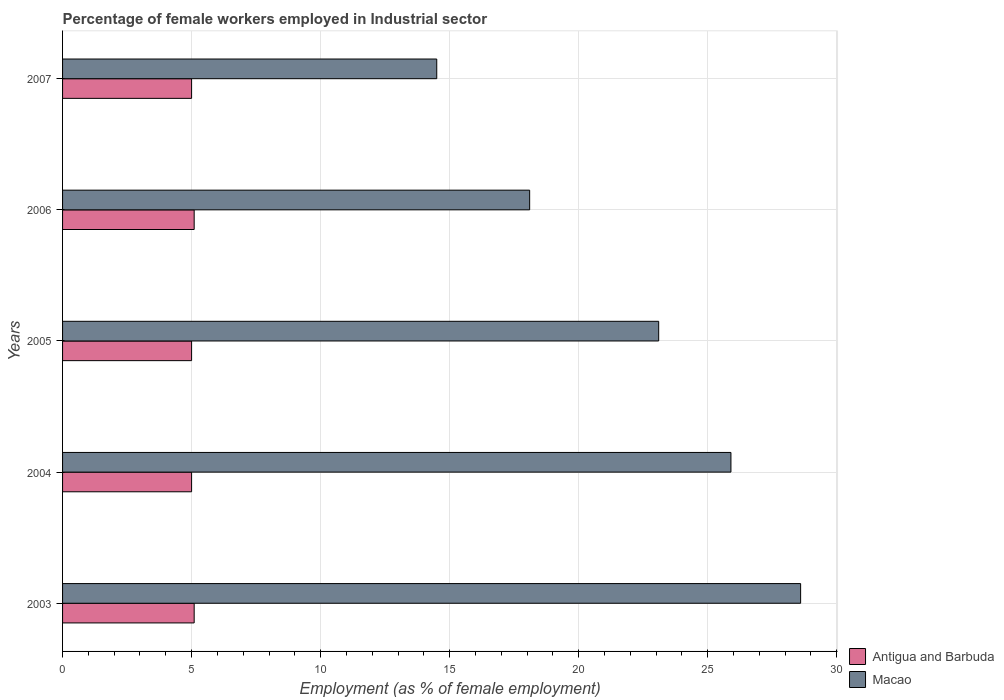Are the number of bars per tick equal to the number of legend labels?
Offer a terse response. Yes. Are the number of bars on each tick of the Y-axis equal?
Provide a short and direct response. Yes. In how many cases, is the number of bars for a given year not equal to the number of legend labels?
Your answer should be compact. 0. Across all years, what is the maximum percentage of females employed in Industrial sector in Macao?
Offer a terse response. 28.6. Across all years, what is the minimum percentage of females employed in Industrial sector in Macao?
Keep it short and to the point. 14.5. In which year was the percentage of females employed in Industrial sector in Antigua and Barbuda maximum?
Give a very brief answer. 2003. What is the total percentage of females employed in Industrial sector in Antigua and Barbuda in the graph?
Keep it short and to the point. 25.2. What is the difference between the percentage of females employed in Industrial sector in Antigua and Barbuda in 2004 and that in 2007?
Offer a terse response. 0. What is the difference between the percentage of females employed in Industrial sector in Macao in 2004 and the percentage of females employed in Industrial sector in Antigua and Barbuda in 2003?
Provide a succinct answer. 20.8. What is the average percentage of females employed in Industrial sector in Macao per year?
Offer a very short reply. 22.04. In how many years, is the percentage of females employed in Industrial sector in Antigua and Barbuda greater than 11 %?
Make the answer very short. 0. What is the ratio of the percentage of females employed in Industrial sector in Antigua and Barbuda in 2003 to that in 2007?
Provide a short and direct response. 1.02. Is the percentage of females employed in Industrial sector in Macao in 2003 less than that in 2006?
Make the answer very short. No. Is the difference between the percentage of females employed in Industrial sector in Macao in 2003 and 2006 greater than the difference between the percentage of females employed in Industrial sector in Antigua and Barbuda in 2003 and 2006?
Ensure brevity in your answer.  Yes. What is the difference between the highest and the second highest percentage of females employed in Industrial sector in Macao?
Give a very brief answer. 2.7. What is the difference between the highest and the lowest percentage of females employed in Industrial sector in Antigua and Barbuda?
Your answer should be very brief. 0.1. Is the sum of the percentage of females employed in Industrial sector in Antigua and Barbuda in 2003 and 2006 greater than the maximum percentage of females employed in Industrial sector in Macao across all years?
Provide a short and direct response. No. What does the 1st bar from the top in 2005 represents?
Offer a very short reply. Macao. What does the 1st bar from the bottom in 2003 represents?
Provide a short and direct response. Antigua and Barbuda. How many bars are there?
Provide a succinct answer. 10. How many years are there in the graph?
Provide a succinct answer. 5. What is the difference between two consecutive major ticks on the X-axis?
Provide a succinct answer. 5. What is the title of the graph?
Your response must be concise. Percentage of female workers employed in Industrial sector. Does "Costa Rica" appear as one of the legend labels in the graph?
Offer a terse response. No. What is the label or title of the X-axis?
Offer a very short reply. Employment (as % of female employment). What is the Employment (as % of female employment) in Antigua and Barbuda in 2003?
Your answer should be compact. 5.1. What is the Employment (as % of female employment) of Macao in 2003?
Your answer should be compact. 28.6. What is the Employment (as % of female employment) of Macao in 2004?
Your answer should be very brief. 25.9. What is the Employment (as % of female employment) in Macao in 2005?
Make the answer very short. 23.1. What is the Employment (as % of female employment) of Antigua and Barbuda in 2006?
Ensure brevity in your answer.  5.1. What is the Employment (as % of female employment) in Macao in 2006?
Provide a succinct answer. 18.1. What is the Employment (as % of female employment) of Antigua and Barbuda in 2007?
Provide a short and direct response. 5. What is the Employment (as % of female employment) in Macao in 2007?
Ensure brevity in your answer.  14.5. Across all years, what is the maximum Employment (as % of female employment) in Antigua and Barbuda?
Provide a succinct answer. 5.1. Across all years, what is the maximum Employment (as % of female employment) in Macao?
Give a very brief answer. 28.6. Across all years, what is the minimum Employment (as % of female employment) in Macao?
Your answer should be very brief. 14.5. What is the total Employment (as % of female employment) of Antigua and Barbuda in the graph?
Make the answer very short. 25.2. What is the total Employment (as % of female employment) of Macao in the graph?
Your response must be concise. 110.2. What is the difference between the Employment (as % of female employment) in Antigua and Barbuda in 2003 and that in 2004?
Ensure brevity in your answer.  0.1. What is the difference between the Employment (as % of female employment) of Macao in 2004 and that in 2005?
Make the answer very short. 2.8. What is the difference between the Employment (as % of female employment) in Antigua and Barbuda in 2004 and that in 2006?
Ensure brevity in your answer.  -0.1. What is the difference between the Employment (as % of female employment) in Antigua and Barbuda in 2004 and that in 2007?
Your response must be concise. 0. What is the difference between the Employment (as % of female employment) in Macao in 2005 and that in 2007?
Your answer should be very brief. 8.6. What is the difference between the Employment (as % of female employment) of Antigua and Barbuda in 2006 and that in 2007?
Provide a succinct answer. 0.1. What is the difference between the Employment (as % of female employment) of Macao in 2006 and that in 2007?
Offer a very short reply. 3.6. What is the difference between the Employment (as % of female employment) in Antigua and Barbuda in 2003 and the Employment (as % of female employment) in Macao in 2004?
Provide a succinct answer. -20.8. What is the difference between the Employment (as % of female employment) of Antigua and Barbuda in 2003 and the Employment (as % of female employment) of Macao in 2006?
Provide a short and direct response. -13. What is the difference between the Employment (as % of female employment) of Antigua and Barbuda in 2004 and the Employment (as % of female employment) of Macao in 2005?
Your answer should be compact. -18.1. What is the difference between the Employment (as % of female employment) of Antigua and Barbuda in 2006 and the Employment (as % of female employment) of Macao in 2007?
Offer a very short reply. -9.4. What is the average Employment (as % of female employment) in Antigua and Barbuda per year?
Provide a short and direct response. 5.04. What is the average Employment (as % of female employment) of Macao per year?
Your answer should be very brief. 22.04. In the year 2003, what is the difference between the Employment (as % of female employment) of Antigua and Barbuda and Employment (as % of female employment) of Macao?
Provide a short and direct response. -23.5. In the year 2004, what is the difference between the Employment (as % of female employment) of Antigua and Barbuda and Employment (as % of female employment) of Macao?
Make the answer very short. -20.9. In the year 2005, what is the difference between the Employment (as % of female employment) in Antigua and Barbuda and Employment (as % of female employment) in Macao?
Offer a very short reply. -18.1. In the year 2006, what is the difference between the Employment (as % of female employment) in Antigua and Barbuda and Employment (as % of female employment) in Macao?
Ensure brevity in your answer.  -13. What is the ratio of the Employment (as % of female employment) of Antigua and Barbuda in 2003 to that in 2004?
Make the answer very short. 1.02. What is the ratio of the Employment (as % of female employment) of Macao in 2003 to that in 2004?
Your answer should be compact. 1.1. What is the ratio of the Employment (as % of female employment) in Macao in 2003 to that in 2005?
Ensure brevity in your answer.  1.24. What is the ratio of the Employment (as % of female employment) of Antigua and Barbuda in 2003 to that in 2006?
Give a very brief answer. 1. What is the ratio of the Employment (as % of female employment) of Macao in 2003 to that in 2006?
Provide a succinct answer. 1.58. What is the ratio of the Employment (as % of female employment) in Antigua and Barbuda in 2003 to that in 2007?
Ensure brevity in your answer.  1.02. What is the ratio of the Employment (as % of female employment) of Macao in 2003 to that in 2007?
Ensure brevity in your answer.  1.97. What is the ratio of the Employment (as % of female employment) in Macao in 2004 to that in 2005?
Ensure brevity in your answer.  1.12. What is the ratio of the Employment (as % of female employment) in Antigua and Barbuda in 2004 to that in 2006?
Your response must be concise. 0.98. What is the ratio of the Employment (as % of female employment) of Macao in 2004 to that in 2006?
Keep it short and to the point. 1.43. What is the ratio of the Employment (as % of female employment) of Antigua and Barbuda in 2004 to that in 2007?
Offer a very short reply. 1. What is the ratio of the Employment (as % of female employment) in Macao in 2004 to that in 2007?
Offer a very short reply. 1.79. What is the ratio of the Employment (as % of female employment) of Antigua and Barbuda in 2005 to that in 2006?
Your response must be concise. 0.98. What is the ratio of the Employment (as % of female employment) of Macao in 2005 to that in 2006?
Offer a terse response. 1.28. What is the ratio of the Employment (as % of female employment) of Macao in 2005 to that in 2007?
Make the answer very short. 1.59. What is the ratio of the Employment (as % of female employment) of Antigua and Barbuda in 2006 to that in 2007?
Offer a very short reply. 1.02. What is the ratio of the Employment (as % of female employment) of Macao in 2006 to that in 2007?
Give a very brief answer. 1.25. What is the difference between the highest and the second highest Employment (as % of female employment) of Antigua and Barbuda?
Make the answer very short. 0. What is the difference between the highest and the second highest Employment (as % of female employment) of Macao?
Provide a short and direct response. 2.7. What is the difference between the highest and the lowest Employment (as % of female employment) in Macao?
Give a very brief answer. 14.1. 